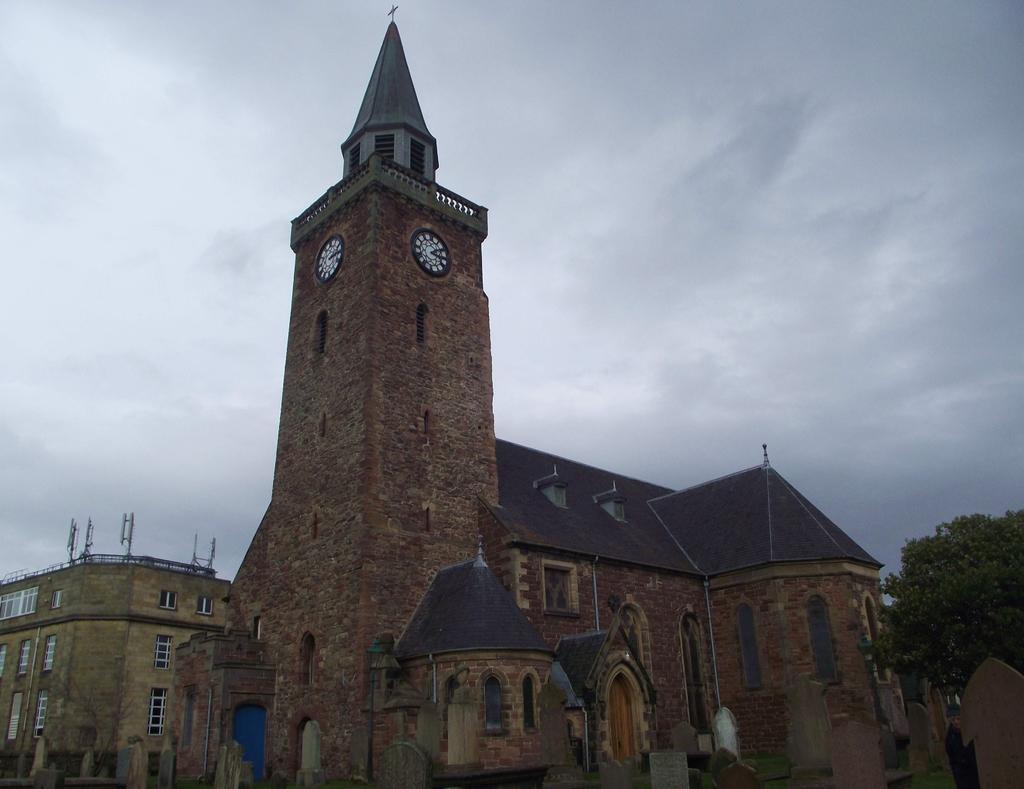How would you summarize this image in a sentence or two? In this image we can see a building. In front of the building there are memorial stones. Beside the building we can see a tree. On the building there are antennas and clocks. Behind the building we can see the sky. 